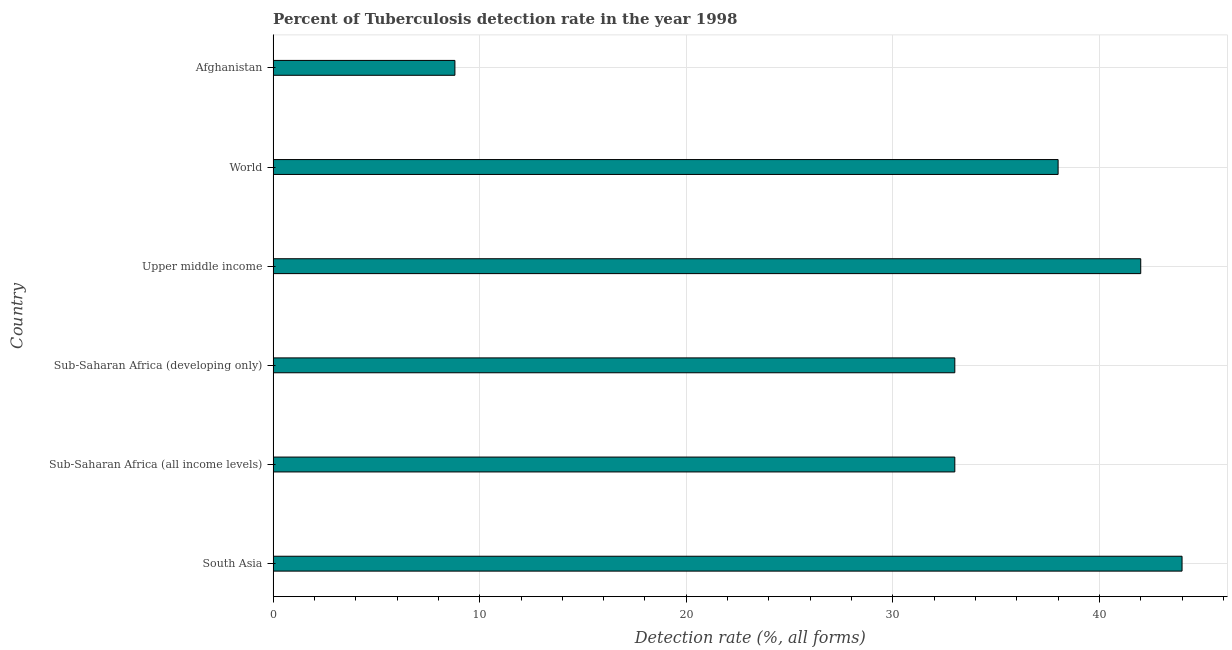Does the graph contain any zero values?
Offer a very short reply. No. Does the graph contain grids?
Your answer should be compact. Yes. What is the title of the graph?
Provide a short and direct response. Percent of Tuberculosis detection rate in the year 1998. What is the label or title of the X-axis?
Make the answer very short. Detection rate (%, all forms). What is the detection rate of tuberculosis in Sub-Saharan Africa (developing only)?
Provide a short and direct response. 33. Across all countries, what is the minimum detection rate of tuberculosis?
Offer a terse response. 8.8. In which country was the detection rate of tuberculosis maximum?
Your answer should be very brief. South Asia. In which country was the detection rate of tuberculosis minimum?
Provide a succinct answer. Afghanistan. What is the sum of the detection rate of tuberculosis?
Provide a short and direct response. 198.8. What is the difference between the detection rate of tuberculosis in Afghanistan and Sub-Saharan Africa (all income levels)?
Your answer should be very brief. -24.2. What is the average detection rate of tuberculosis per country?
Offer a terse response. 33.13. What is the median detection rate of tuberculosis?
Ensure brevity in your answer.  35.5. In how many countries, is the detection rate of tuberculosis greater than 26 %?
Provide a short and direct response. 5. What is the ratio of the detection rate of tuberculosis in Upper middle income to that in World?
Provide a short and direct response. 1.1. Is the difference between the detection rate of tuberculosis in Afghanistan and Sub-Saharan Africa (developing only) greater than the difference between any two countries?
Keep it short and to the point. No. What is the difference between the highest and the lowest detection rate of tuberculosis?
Ensure brevity in your answer.  35.2. Are all the bars in the graph horizontal?
Make the answer very short. Yes. What is the Detection rate (%, all forms) in South Asia?
Offer a very short reply. 44. What is the Detection rate (%, all forms) of Sub-Saharan Africa (developing only)?
Your response must be concise. 33. What is the Detection rate (%, all forms) of World?
Your answer should be compact. 38. What is the difference between the Detection rate (%, all forms) in South Asia and Sub-Saharan Africa (all income levels)?
Your answer should be compact. 11. What is the difference between the Detection rate (%, all forms) in South Asia and Sub-Saharan Africa (developing only)?
Provide a short and direct response. 11. What is the difference between the Detection rate (%, all forms) in South Asia and Afghanistan?
Ensure brevity in your answer.  35.2. What is the difference between the Detection rate (%, all forms) in Sub-Saharan Africa (all income levels) and Sub-Saharan Africa (developing only)?
Your response must be concise. 0. What is the difference between the Detection rate (%, all forms) in Sub-Saharan Africa (all income levels) and World?
Offer a very short reply. -5. What is the difference between the Detection rate (%, all forms) in Sub-Saharan Africa (all income levels) and Afghanistan?
Keep it short and to the point. 24.2. What is the difference between the Detection rate (%, all forms) in Sub-Saharan Africa (developing only) and World?
Provide a short and direct response. -5. What is the difference between the Detection rate (%, all forms) in Sub-Saharan Africa (developing only) and Afghanistan?
Give a very brief answer. 24.2. What is the difference between the Detection rate (%, all forms) in Upper middle income and World?
Your response must be concise. 4. What is the difference between the Detection rate (%, all forms) in Upper middle income and Afghanistan?
Give a very brief answer. 33.2. What is the difference between the Detection rate (%, all forms) in World and Afghanistan?
Give a very brief answer. 29.2. What is the ratio of the Detection rate (%, all forms) in South Asia to that in Sub-Saharan Africa (all income levels)?
Make the answer very short. 1.33. What is the ratio of the Detection rate (%, all forms) in South Asia to that in Sub-Saharan Africa (developing only)?
Keep it short and to the point. 1.33. What is the ratio of the Detection rate (%, all forms) in South Asia to that in Upper middle income?
Provide a succinct answer. 1.05. What is the ratio of the Detection rate (%, all forms) in South Asia to that in World?
Ensure brevity in your answer.  1.16. What is the ratio of the Detection rate (%, all forms) in Sub-Saharan Africa (all income levels) to that in Upper middle income?
Ensure brevity in your answer.  0.79. What is the ratio of the Detection rate (%, all forms) in Sub-Saharan Africa (all income levels) to that in World?
Your response must be concise. 0.87. What is the ratio of the Detection rate (%, all forms) in Sub-Saharan Africa (all income levels) to that in Afghanistan?
Your answer should be very brief. 3.75. What is the ratio of the Detection rate (%, all forms) in Sub-Saharan Africa (developing only) to that in Upper middle income?
Provide a short and direct response. 0.79. What is the ratio of the Detection rate (%, all forms) in Sub-Saharan Africa (developing only) to that in World?
Make the answer very short. 0.87. What is the ratio of the Detection rate (%, all forms) in Sub-Saharan Africa (developing only) to that in Afghanistan?
Provide a succinct answer. 3.75. What is the ratio of the Detection rate (%, all forms) in Upper middle income to that in World?
Provide a short and direct response. 1.1. What is the ratio of the Detection rate (%, all forms) in Upper middle income to that in Afghanistan?
Provide a short and direct response. 4.77. What is the ratio of the Detection rate (%, all forms) in World to that in Afghanistan?
Your response must be concise. 4.32. 